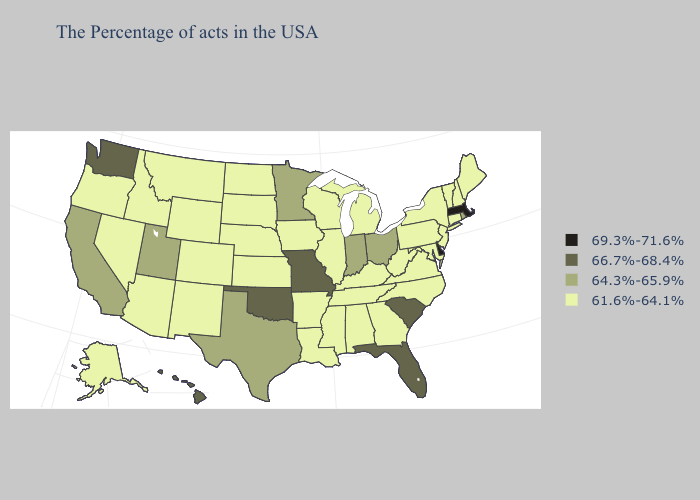Name the states that have a value in the range 66.7%-68.4%?
Quick response, please. South Carolina, Florida, Missouri, Oklahoma, Washington, Hawaii. Name the states that have a value in the range 64.3%-65.9%?
Short answer required. Rhode Island, Ohio, Indiana, Minnesota, Texas, Utah, California. Does Louisiana have a lower value than Alaska?
Keep it brief. No. Does Massachusetts have the highest value in the Northeast?
Quick response, please. Yes. What is the value of Montana?
Be succinct. 61.6%-64.1%. Which states have the highest value in the USA?
Give a very brief answer. Massachusetts, Delaware. Which states have the lowest value in the USA?
Quick response, please. Maine, New Hampshire, Vermont, Connecticut, New York, New Jersey, Maryland, Pennsylvania, Virginia, North Carolina, West Virginia, Georgia, Michigan, Kentucky, Alabama, Tennessee, Wisconsin, Illinois, Mississippi, Louisiana, Arkansas, Iowa, Kansas, Nebraska, South Dakota, North Dakota, Wyoming, Colorado, New Mexico, Montana, Arizona, Idaho, Nevada, Oregon, Alaska. Does the map have missing data?
Quick response, please. No. What is the value of Virginia?
Answer briefly. 61.6%-64.1%. Does South Dakota have the lowest value in the USA?
Give a very brief answer. Yes. What is the highest value in the USA?
Quick response, please. 69.3%-71.6%. What is the lowest value in states that border Utah?
Quick response, please. 61.6%-64.1%. Among the states that border Michigan , does Indiana have the lowest value?
Short answer required. No. Which states have the highest value in the USA?
Answer briefly. Massachusetts, Delaware. Name the states that have a value in the range 66.7%-68.4%?
Quick response, please. South Carolina, Florida, Missouri, Oklahoma, Washington, Hawaii. 